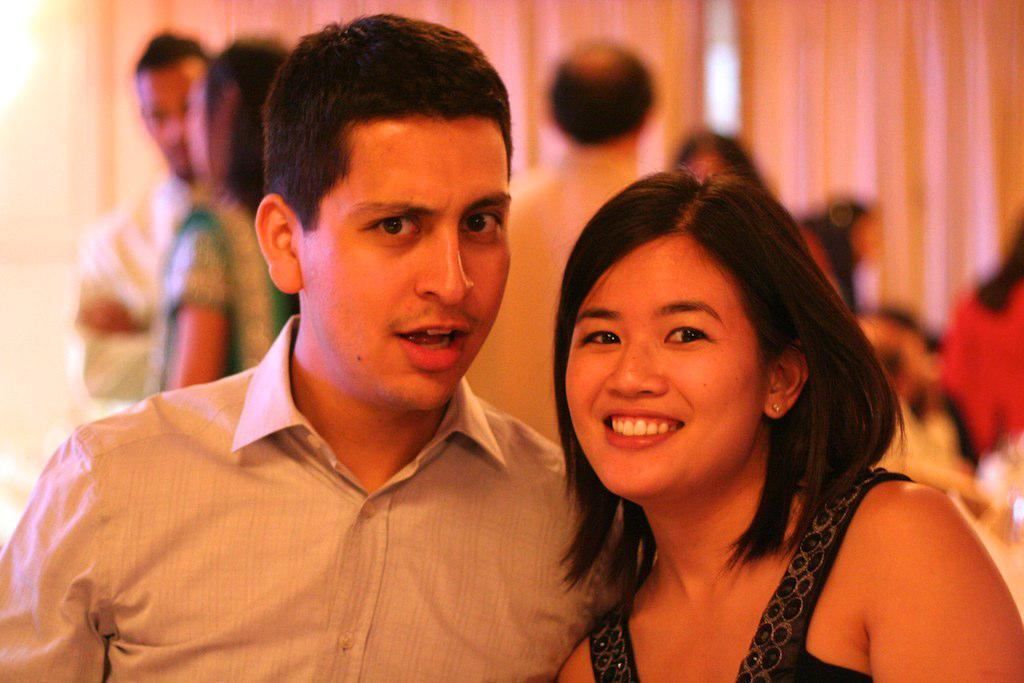Where was the image taken? The image was taken indoors. What can be seen in the background of the image? There are two curtains and people standing in the background. Who are the main subjects in the middle of the image? There is a man and a woman in the middle of the image. What is the facial expression of the man and the woman? Both the man and the woman have smiling faces. What is the aftermath of the event that took place on the bed in the image? There is no bed or event present in the image, so it's not possible to determine the aftermath. What route do the people in the background need to take to reach the man and the woman? There is no information about a route or the need to reach the man and the woman in the image. 